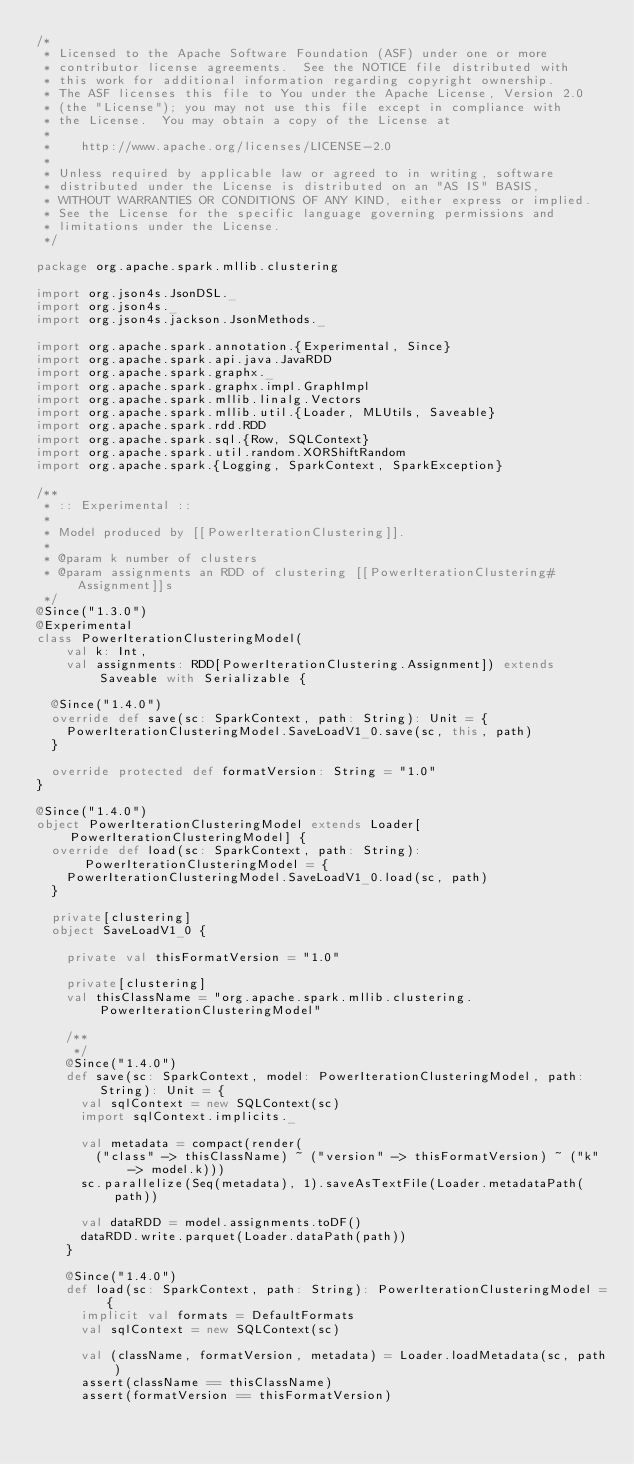Convert code to text. <code><loc_0><loc_0><loc_500><loc_500><_Scala_>/*
 * Licensed to the Apache Software Foundation (ASF) under one or more
 * contributor license agreements.  See the NOTICE file distributed with
 * this work for additional information regarding copyright ownership.
 * The ASF licenses this file to You under the Apache License, Version 2.0
 * (the "License"); you may not use this file except in compliance with
 * the License.  You may obtain a copy of the License at
 *
 *    http://www.apache.org/licenses/LICENSE-2.0
 *
 * Unless required by applicable law or agreed to in writing, software
 * distributed under the License is distributed on an "AS IS" BASIS,
 * WITHOUT WARRANTIES OR CONDITIONS OF ANY KIND, either express or implied.
 * See the License for the specific language governing permissions and
 * limitations under the License.
 */

package org.apache.spark.mllib.clustering

import org.json4s.JsonDSL._
import org.json4s._
import org.json4s.jackson.JsonMethods._

import org.apache.spark.annotation.{Experimental, Since}
import org.apache.spark.api.java.JavaRDD
import org.apache.spark.graphx._
import org.apache.spark.graphx.impl.GraphImpl
import org.apache.spark.mllib.linalg.Vectors
import org.apache.spark.mllib.util.{Loader, MLUtils, Saveable}
import org.apache.spark.rdd.RDD
import org.apache.spark.sql.{Row, SQLContext}
import org.apache.spark.util.random.XORShiftRandom
import org.apache.spark.{Logging, SparkContext, SparkException}

/**
 * :: Experimental ::
 *
 * Model produced by [[PowerIterationClustering]].
 *
 * @param k number of clusters
 * @param assignments an RDD of clustering [[PowerIterationClustering#Assignment]]s
 */
@Since("1.3.0")
@Experimental
class PowerIterationClusteringModel(
    val k: Int,
    val assignments: RDD[PowerIterationClustering.Assignment]) extends Saveable with Serializable {

  @Since("1.4.0")
  override def save(sc: SparkContext, path: String): Unit = {
    PowerIterationClusteringModel.SaveLoadV1_0.save(sc, this, path)
  }

  override protected def formatVersion: String = "1.0"
}

@Since("1.4.0")
object PowerIterationClusteringModel extends Loader[PowerIterationClusteringModel] {
  override def load(sc: SparkContext, path: String): PowerIterationClusteringModel = {
    PowerIterationClusteringModel.SaveLoadV1_0.load(sc, path)
  }

  private[clustering]
  object SaveLoadV1_0 {

    private val thisFormatVersion = "1.0"

    private[clustering]
    val thisClassName = "org.apache.spark.mllib.clustering.PowerIterationClusteringModel"

    /**
     */
    @Since("1.4.0")
    def save(sc: SparkContext, model: PowerIterationClusteringModel, path: String): Unit = {
      val sqlContext = new SQLContext(sc)
      import sqlContext.implicits._

      val metadata = compact(render(
        ("class" -> thisClassName) ~ ("version" -> thisFormatVersion) ~ ("k" -> model.k)))
      sc.parallelize(Seq(metadata), 1).saveAsTextFile(Loader.metadataPath(path))

      val dataRDD = model.assignments.toDF()
      dataRDD.write.parquet(Loader.dataPath(path))
    }

    @Since("1.4.0")
    def load(sc: SparkContext, path: String): PowerIterationClusteringModel = {
      implicit val formats = DefaultFormats
      val sqlContext = new SQLContext(sc)

      val (className, formatVersion, metadata) = Loader.loadMetadata(sc, path)
      assert(className == thisClassName)
      assert(formatVersion == thisFormatVersion)
</code> 